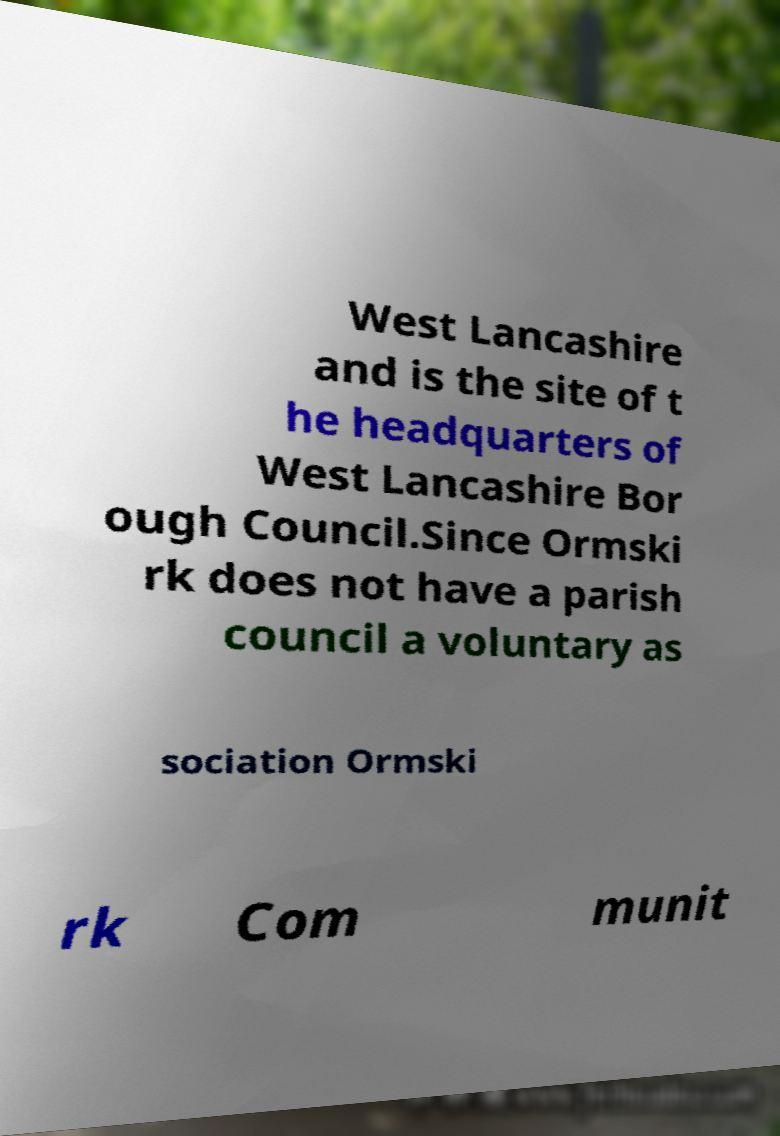I need the written content from this picture converted into text. Can you do that? West Lancashire and is the site of t he headquarters of West Lancashire Bor ough Council.Since Ormski rk does not have a parish council a voluntary as sociation Ormski rk Com munit 